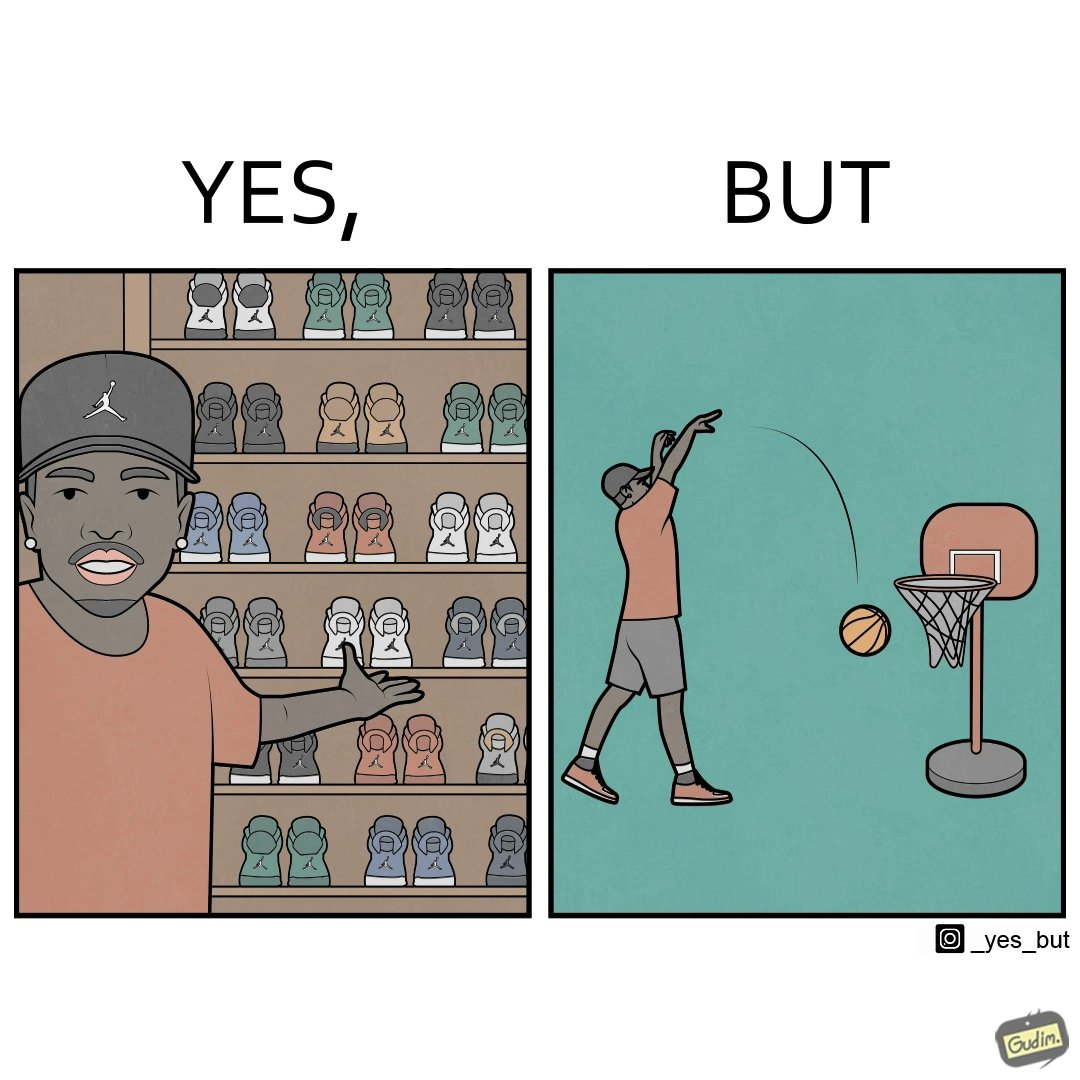What does this image depict? The image is ironic, because even when the person has a large collection of shoes even then he is not able to basket a ball in a small height net 